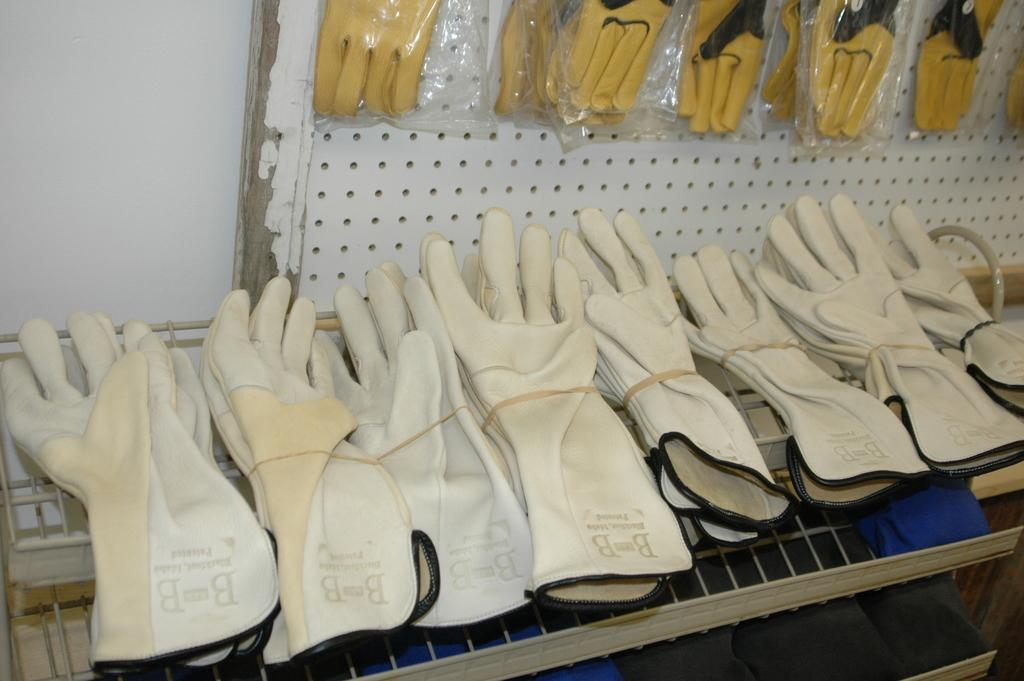What is hanging on the rack in the image? There are many gloves on a rack in the image. Can you describe the gloves on the wall in the image? There are yellow gloves in packets on the wall in the image. What color is the wall in the image? The wall is white in color. What type of metal paste is being used to hold the gloves together in the image? There is no metal paste present in the image; the gloves are simply hanging on a rack or in packets on the wall. 